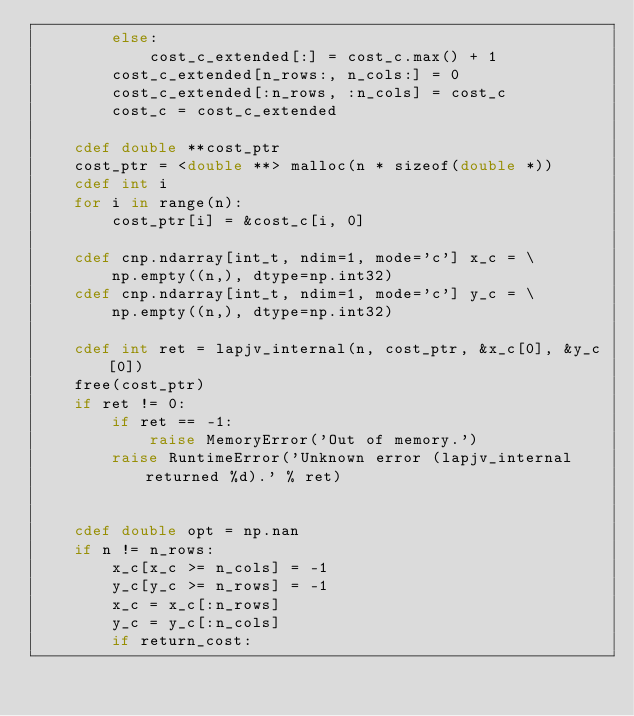<code> <loc_0><loc_0><loc_500><loc_500><_Cython_>        else:
            cost_c_extended[:] = cost_c.max() + 1
        cost_c_extended[n_rows:, n_cols:] = 0
        cost_c_extended[:n_rows, :n_cols] = cost_c
        cost_c = cost_c_extended

    cdef double **cost_ptr
    cost_ptr = <double **> malloc(n * sizeof(double *))
    cdef int i
    for i in range(n):
        cost_ptr[i] = &cost_c[i, 0]

    cdef cnp.ndarray[int_t, ndim=1, mode='c'] x_c = \
        np.empty((n,), dtype=np.int32)
    cdef cnp.ndarray[int_t, ndim=1, mode='c'] y_c = \
        np.empty((n,), dtype=np.int32)

    cdef int ret = lapjv_internal(n, cost_ptr, &x_c[0], &y_c[0])
    free(cost_ptr)
    if ret != 0:
        if ret == -1:
            raise MemoryError('Out of memory.')
        raise RuntimeError('Unknown error (lapjv_internal returned %d).' % ret)


    cdef double opt = np.nan
    if n != n_rows:
        x_c[x_c >= n_cols] = -1
        y_c[y_c >= n_rows] = -1
        x_c = x_c[:n_rows]
        y_c = y_c[:n_cols]
        if return_cost:</code> 